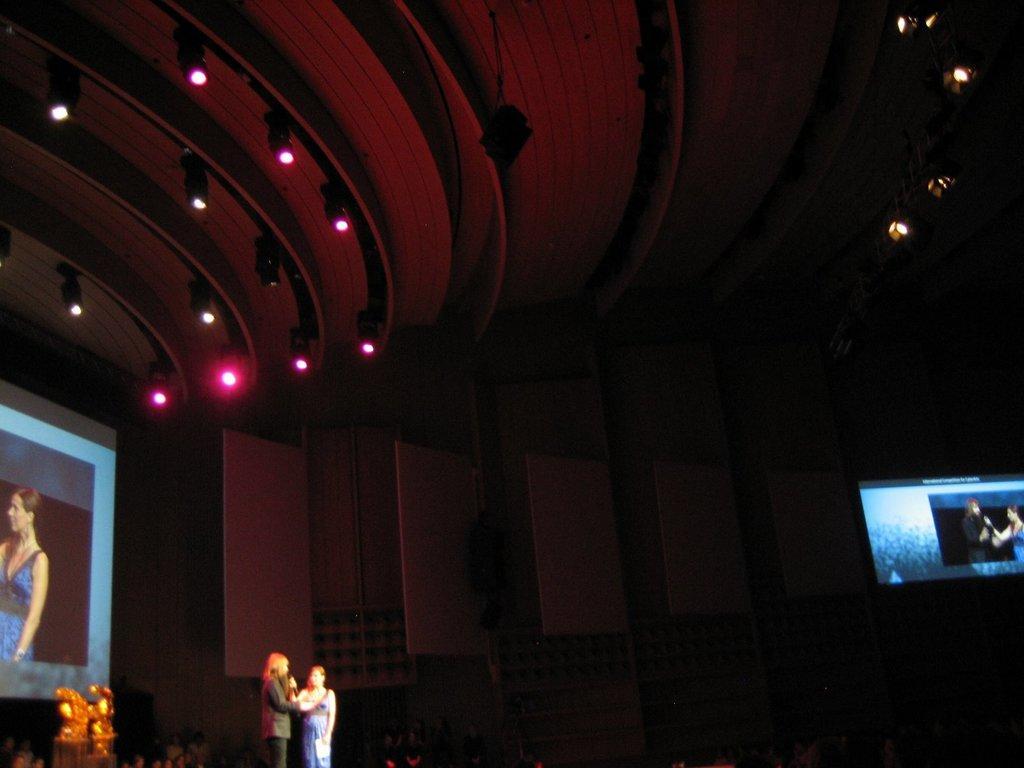Can you describe this image briefly? Here we can see two women and a woman is holding a mike in her hand. In the background there are screens,boards on the wall,lights on the ceiling,on the left at the bottom there is an object and few persons. 